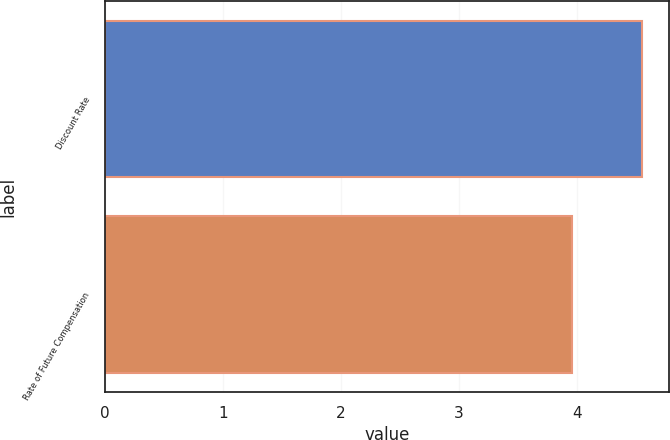Convert chart. <chart><loc_0><loc_0><loc_500><loc_500><bar_chart><fcel>Discount Rate<fcel>Rate of Future Compensation<nl><fcel>4.55<fcel>3.96<nl></chart> 